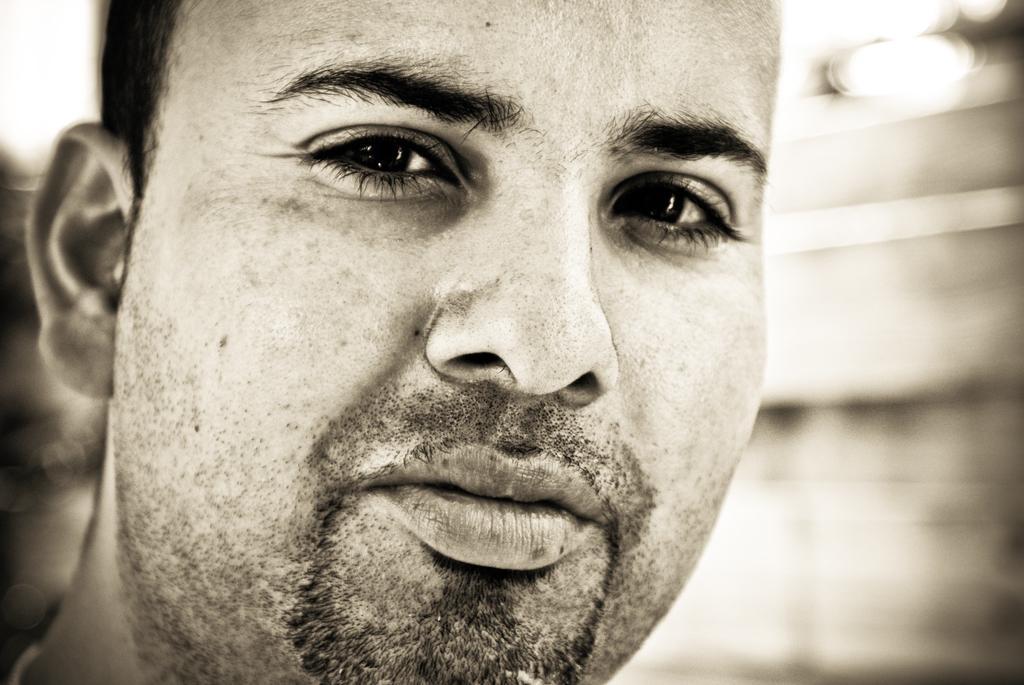How would you summarize this image in a sentence or two? In this picture we can see a man´s face, we can see a blurry background here. 